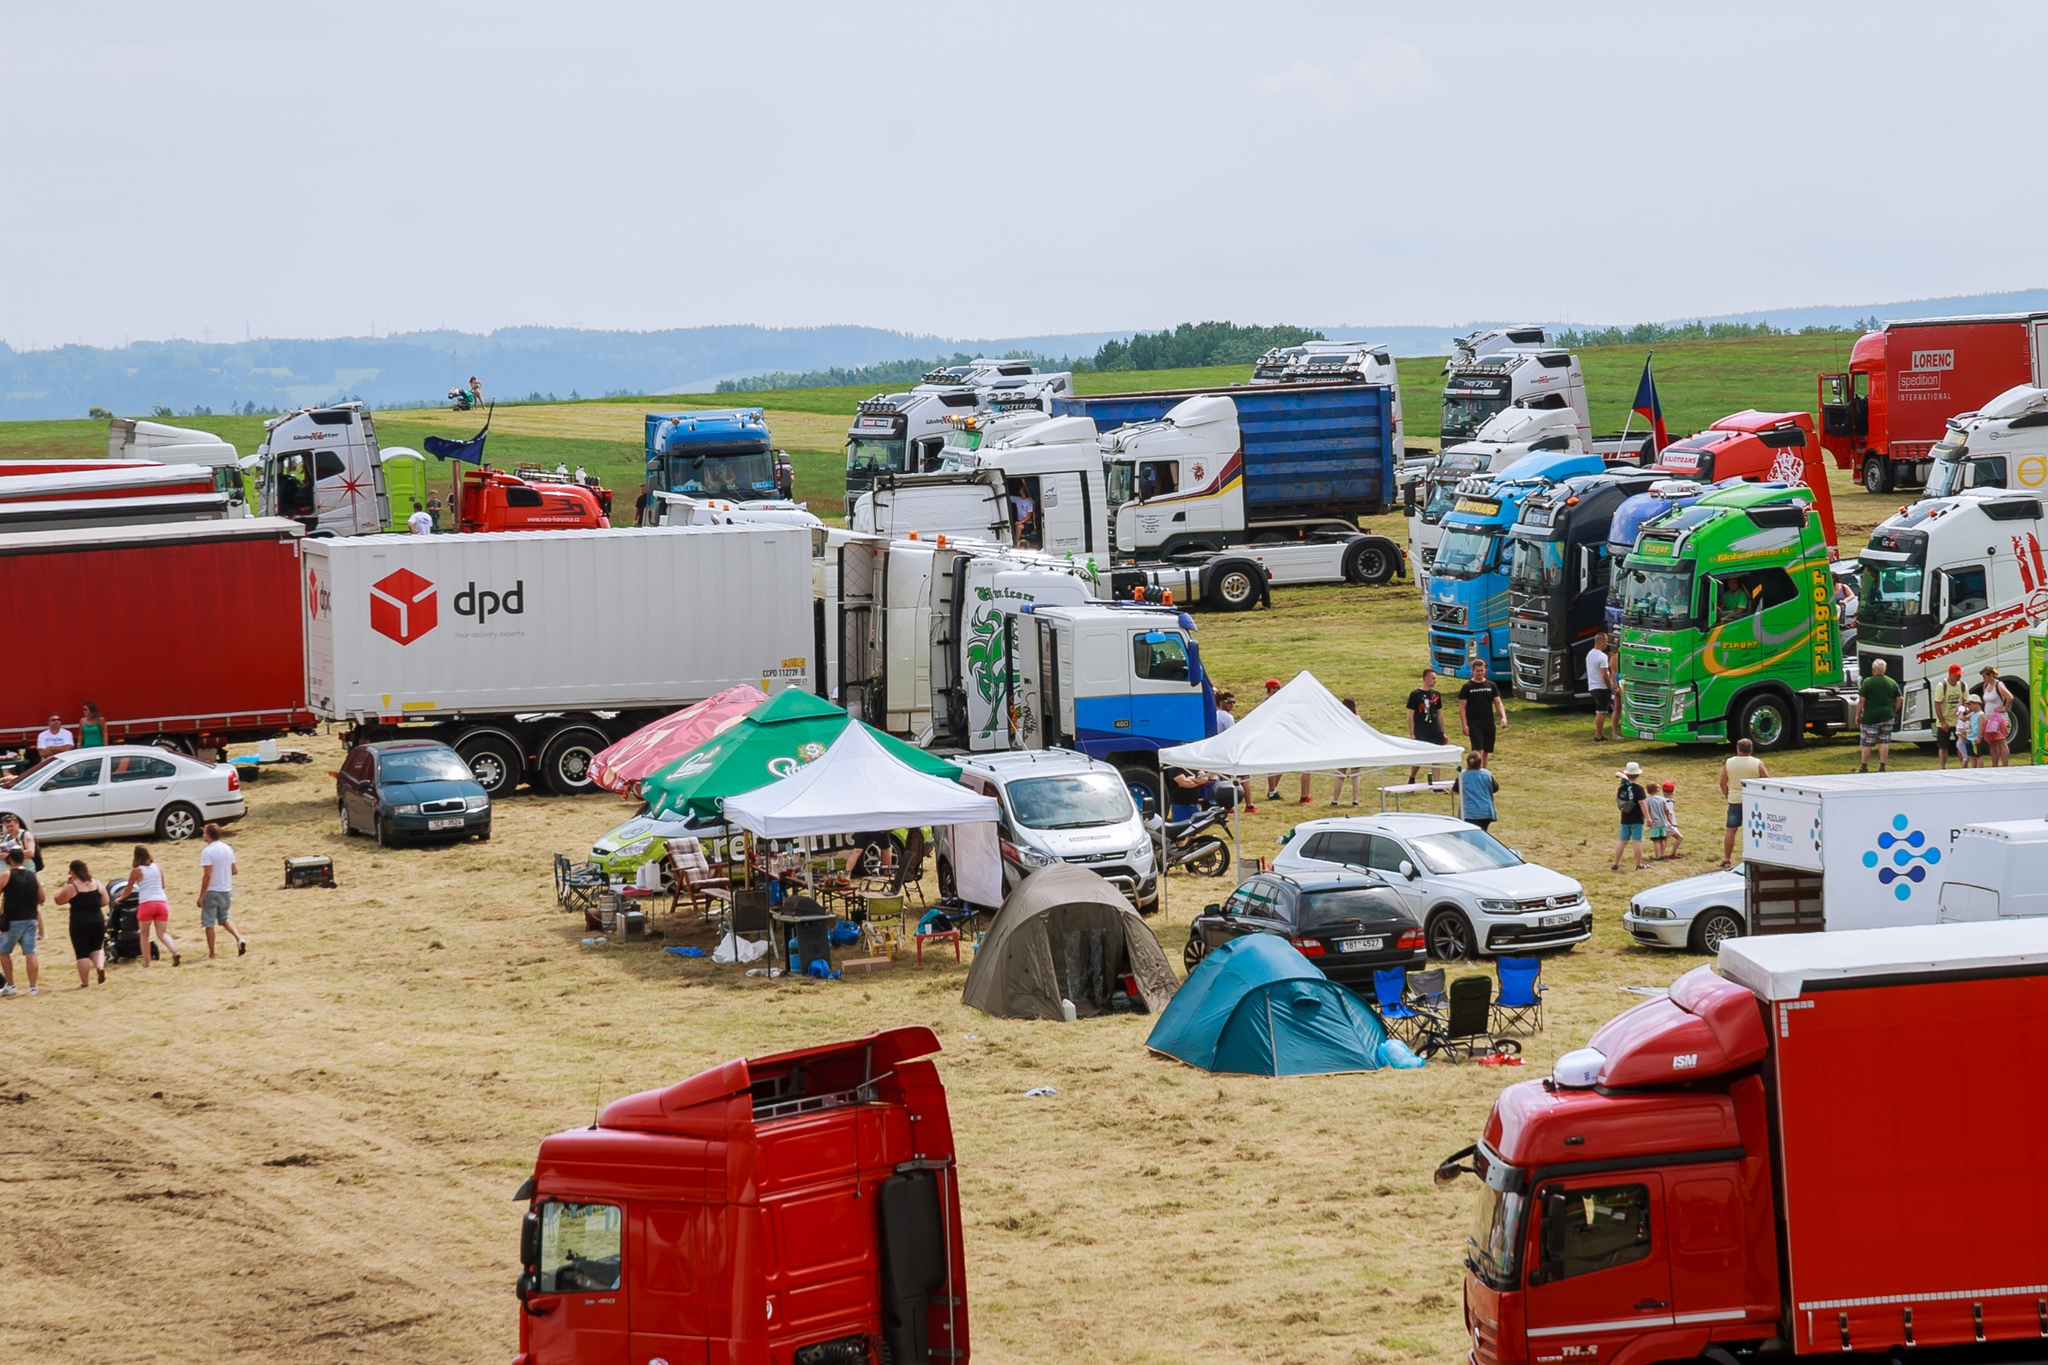Is there any indication of what time of year this event might be taking place? The photo shows an overcast sky and people dressed in light, casual clothing, suggesting that the event could be taking place during a warmer season, likely late spring or summer. The grass is lush and green, further reinforcing the likelihood of a summertime setting. The absence of any significant rain gear or heavy clothing among the attendees might indicate fair weather, despite the cloud cover. 